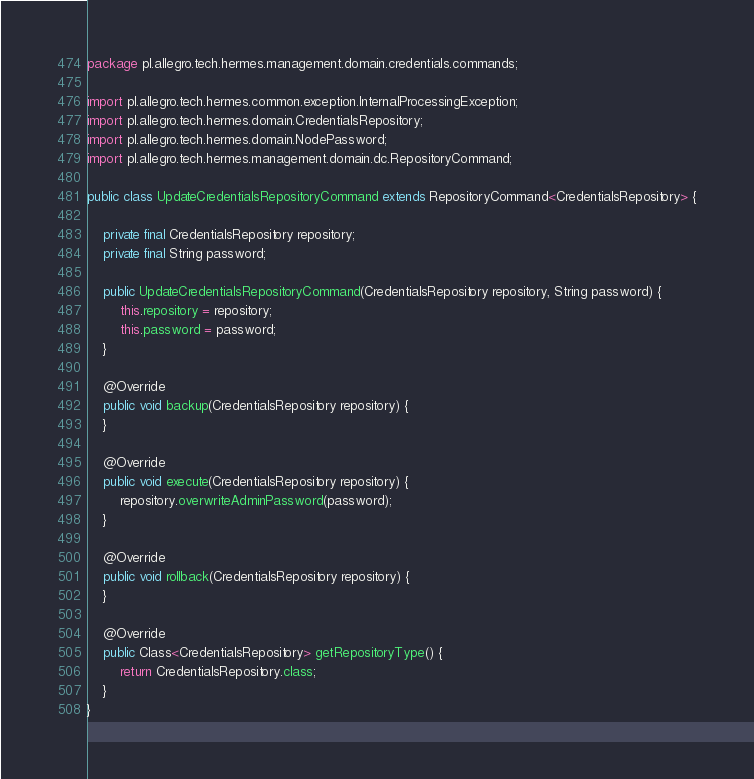Convert code to text. <code><loc_0><loc_0><loc_500><loc_500><_Java_>package pl.allegro.tech.hermes.management.domain.credentials.commands;

import pl.allegro.tech.hermes.common.exception.InternalProcessingException;
import pl.allegro.tech.hermes.domain.CredentialsRepository;
import pl.allegro.tech.hermes.domain.NodePassword;
import pl.allegro.tech.hermes.management.domain.dc.RepositoryCommand;

public class UpdateCredentialsRepositoryCommand extends RepositoryCommand<CredentialsRepository> {

    private final CredentialsRepository repository;
    private final String password;

    public UpdateCredentialsRepositoryCommand(CredentialsRepository repository, String password) {
        this.repository = repository;
        this.password = password;
    }

    @Override
    public void backup(CredentialsRepository repository) {
    }

    @Override
    public void execute(CredentialsRepository repository) {
        repository.overwriteAdminPassword(password);
    }

    @Override
    public void rollback(CredentialsRepository repository) {
    }

    @Override
    public Class<CredentialsRepository> getRepositoryType() {
        return CredentialsRepository.class;
    }
}
</code> 